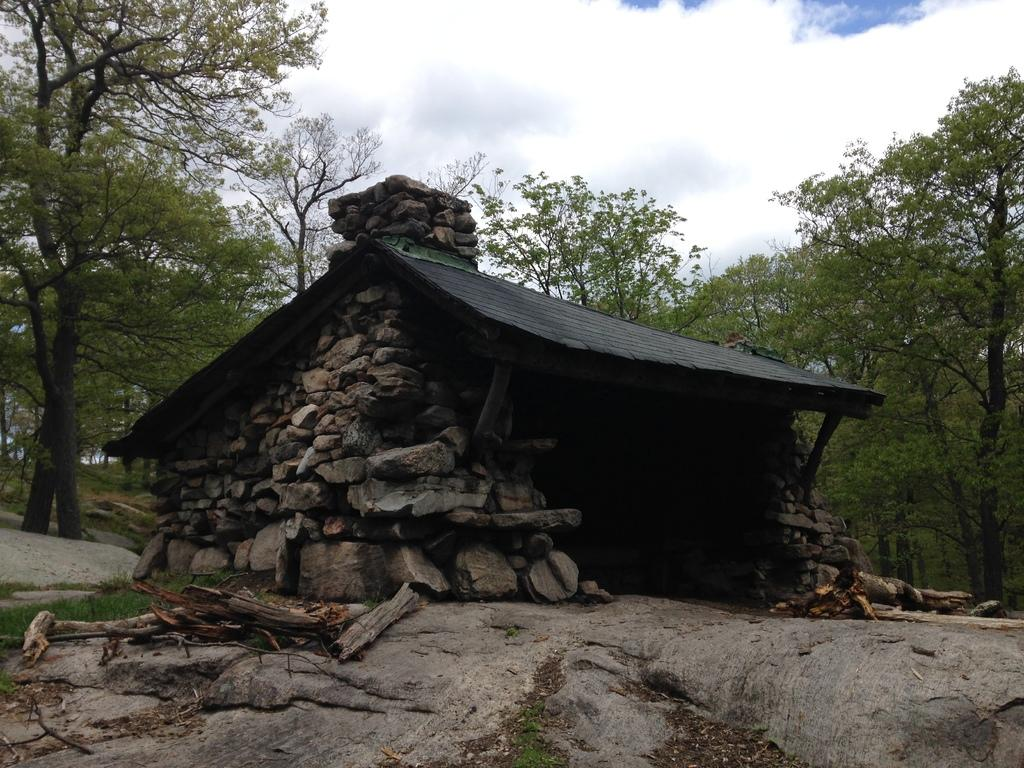What type of structure is located on a rock in the image? There is a house on a rock in the image. What can be seen on the ground near the house? There are sticks on the ground in the image. What type of vegetation is visible in the image? There are trees visible in the image. How would you describe the sky in the image? The sky is blue and cloudy in the image. How much payment is required to enter the house in the image? A: There is no mention of payment or entering the house in the image. 